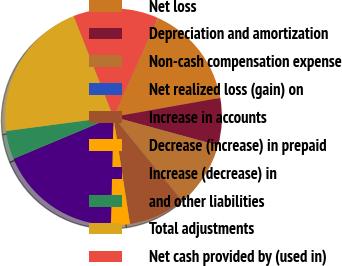Convert chart. <chart><loc_0><loc_0><loc_500><loc_500><pie_chart><fcel>Net loss<fcel>Depreciation and amortization<fcel>Non-cash compensation expense<fcel>Net realized loss (gain) on<fcel>Increase in accounts<fcel>Decrease (increase) in prepaid<fcel>Increase (decrease) in<fcel>and other liabilities<fcel>Total adjustments<fcel>Net cash provided by (used in)<nl><fcel>15.49%<fcel>7.04%<fcel>9.86%<fcel>0.01%<fcel>8.45%<fcel>2.82%<fcel>18.3%<fcel>4.23%<fcel>21.12%<fcel>12.67%<nl></chart> 